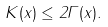<formula> <loc_0><loc_0><loc_500><loc_500>K ( x ) \leq 2 \Gamma ( x ) .</formula> 